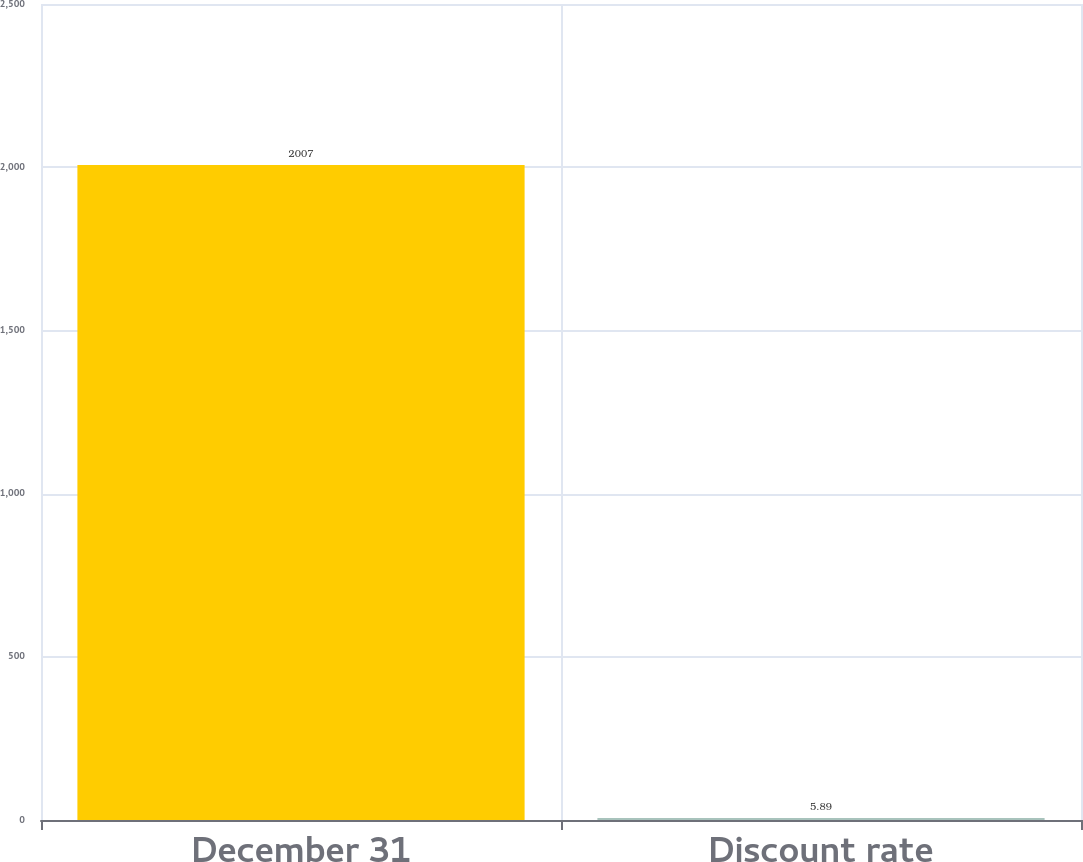Convert chart to OTSL. <chart><loc_0><loc_0><loc_500><loc_500><bar_chart><fcel>December 31<fcel>Discount rate<nl><fcel>2007<fcel>5.89<nl></chart> 